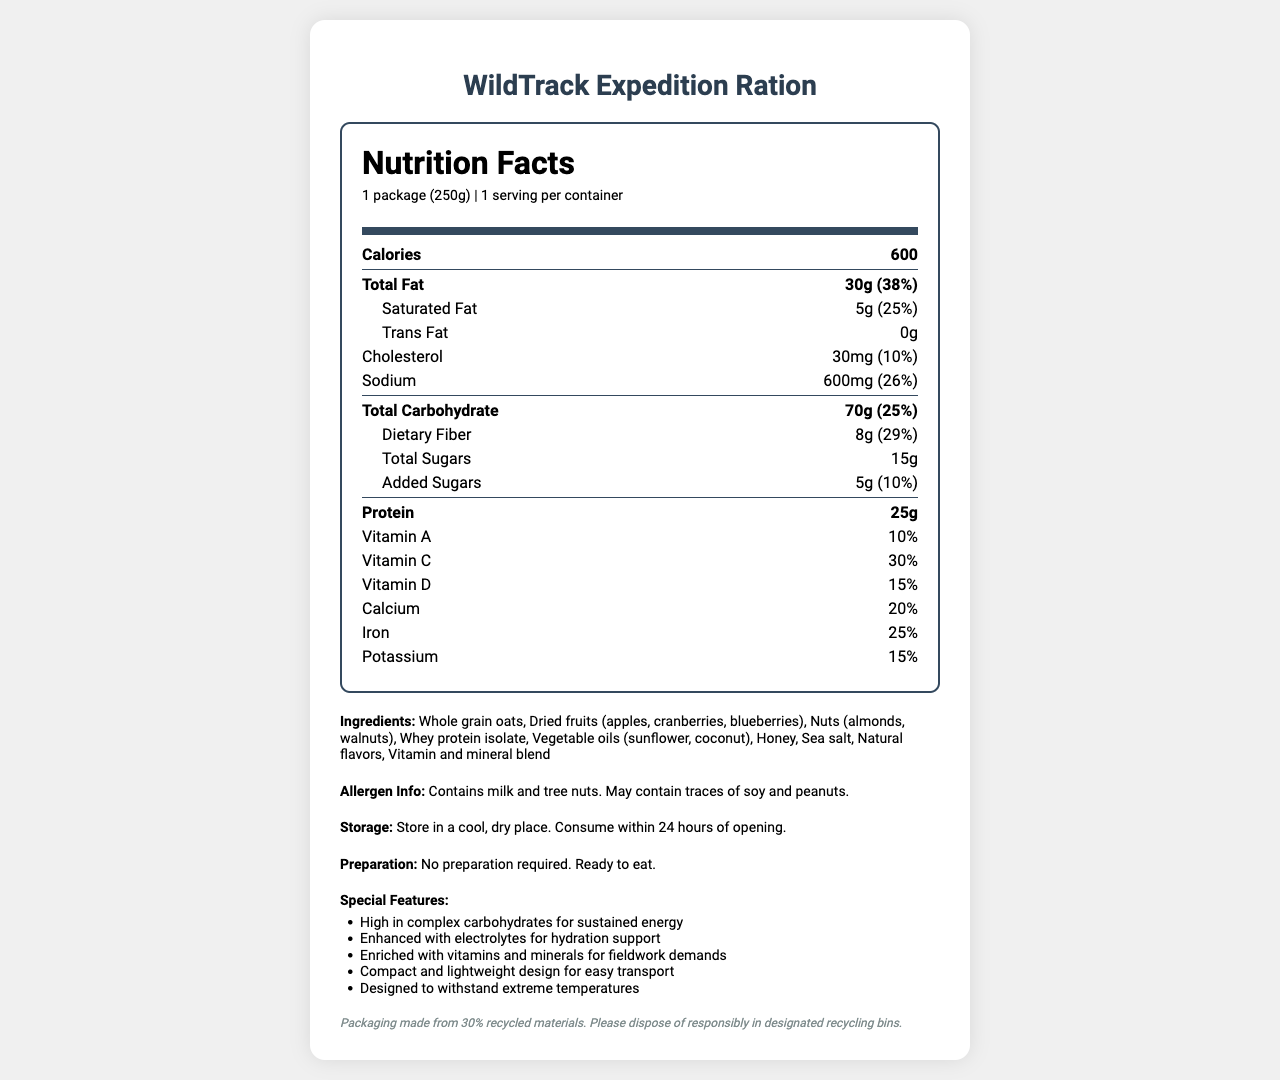What is the serving size of the WildTrack Expedition Ration? The serving size is clearly labeled as "1 package (250g)" at the top of the nutrition label.
Answer: 1 package (250g) How many calories are in one serving of the WildTrack Expedition Ration? The calories per serving are listed directly under the Nutrition Facts title at the top of the label.
Answer: 600 How much protein is in one serving of the WildTrack Expedition Ration? The protein content is specified under the nutrition details as "25g".
Answer: 25g What is the percentage daily value of saturated fat in the WildTrack Expedition Ration? The daily value percentage for saturated fat is listed as "25%" right next to the amount of saturated fat.
Answer: 25% Which vitamins are enhanced in the WildTrack Expedition Ration? The vitamins enhanced in the ration are Vitamin A (10%), Vitamin C (30%), and Vitamin D (15%), which are listed in the nutrition facts section.
Answer: Vitamin A, Vitamin C, Vitamin D What allergens are present in the WildTrack Expedition Ration? The allergen information specifies that the product "Contains milk and tree nuts".
Answer: Milk and tree nuts What is the total amount of carbohydrates in one serving of the WildTrack Expedition Ration? The total carbohydrates per serving are listed as "70g" in the nutrition facts.
Answer: 70g By what percentage of the daily value does the WildTrack Expedition Ration contribute to iron intake? The daily value contribution for iron is listed as "25%" in the nutrition facts.
Answer: 25% How should the WildTrack Expedition Ration be stored? The storage instructions are detailed under the storage section as "Store in a cool, dry place. Consume within 24 hours of opening."
Answer: Store in a cool, dry place. Consume within 24 hours of opening. Is any preparation required for the WildTrack Expedition Ration? The document states that no preparation is required: "Ready to eat".
Answer: No What percentage of the container is made from recycled materials? A. 10% B. 30% C. 50% D. 70% The conservation note at the end mentions that the packaging is made from "30% recycled materials."
Answer: B. 30% Which ingredient is not listed in the WildTrack Expedition Ration? A. Honey B. Chocolate C. Sea salt D. Nuts The ingredients section does not list chocolate, whereas it lists honey, sea salt, and nuts.
Answer: B. Chocolate Is the WildTrack Expedition Ration high in complex carbohydrates? One of the special features explicitly states "High in complex carbohydrates for sustained energy".
Answer: Yes Summarize the main information presented in the WildTrack Expedition Ration’s nutrition facts label. The label provides detailed nutrition information, ingredients, special features, and usage instructions for the ration, emphasizing its suitability for energy needs during fieldwork.
Answer: The WildTrack Expedition Ration is a high-energy meal designed for long wildlife tracking missions. Each 250g package provides 600 calories, 30g of total fat, 70g of total carbohydrates, and 25g of protein. It also includes a variety of vitamins and minerals, and is enhanced with complex carbohydrates and electrolytes. The product contains milk and tree nuts, and should be stored in a cool, dry place and consumed within 24 hours of opening. No preparation is needed as it is ready to eat. Special features include being compact, lightweight, and able to withstand extreme temperatures. What is the source of specific vitamins and minerals in the WildTrack Expedition Ration? The document does not specify the source of the vitamins and minerals beyond listing them as ingredients and their respective daily values.
Answer: Not enough information 